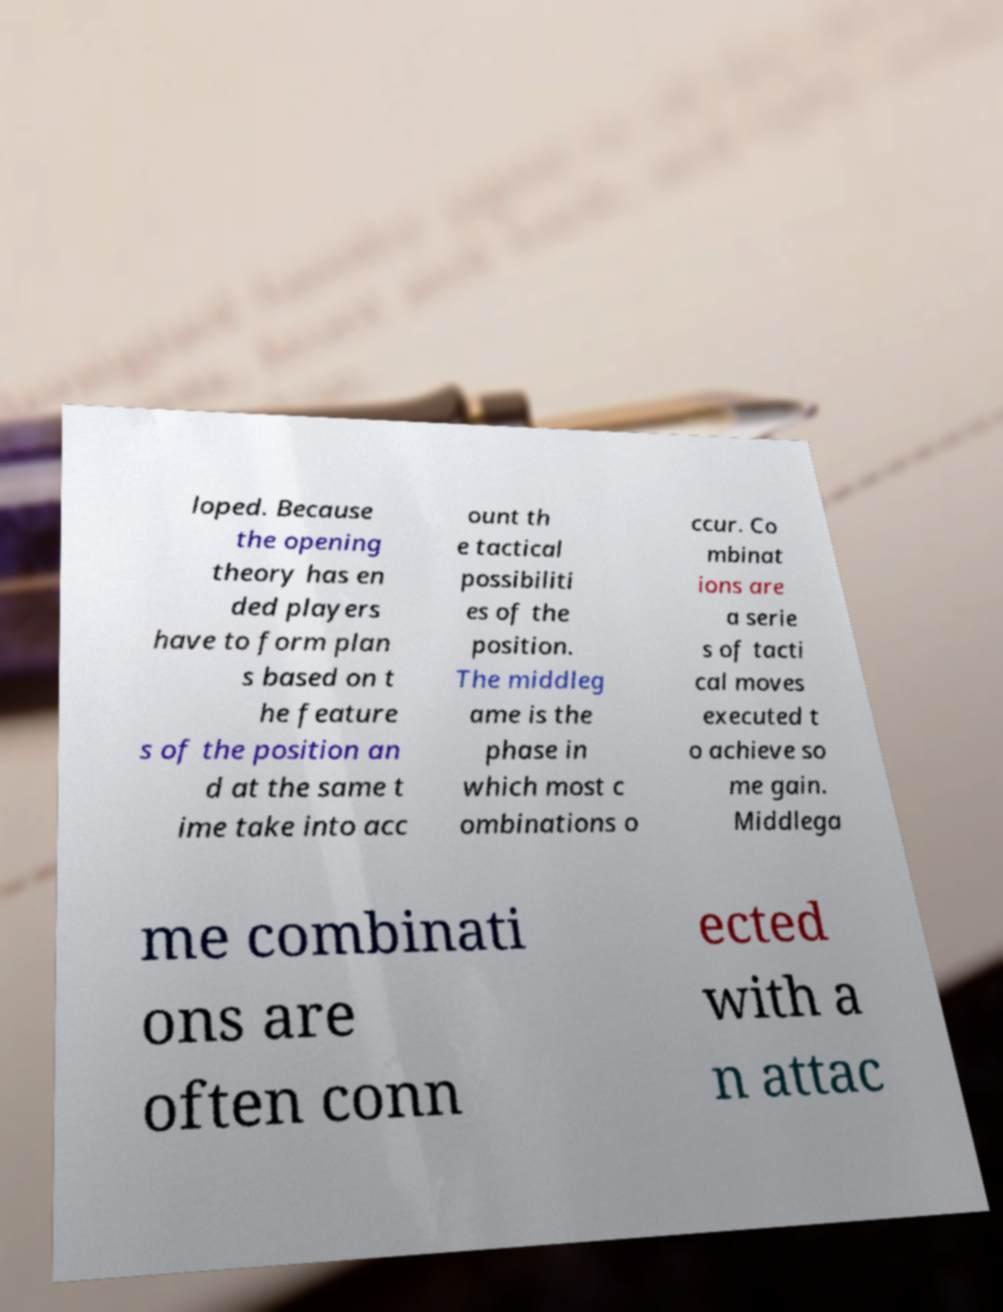Please identify and transcribe the text found in this image. loped. Because the opening theory has en ded players have to form plan s based on t he feature s of the position an d at the same t ime take into acc ount th e tactical possibiliti es of the position. The middleg ame is the phase in which most c ombinations o ccur. Co mbinat ions are a serie s of tacti cal moves executed t o achieve so me gain. Middlega me combinati ons are often conn ected with a n attac 